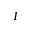<formula> <loc_0><loc_0><loc_500><loc_500>I</formula> 